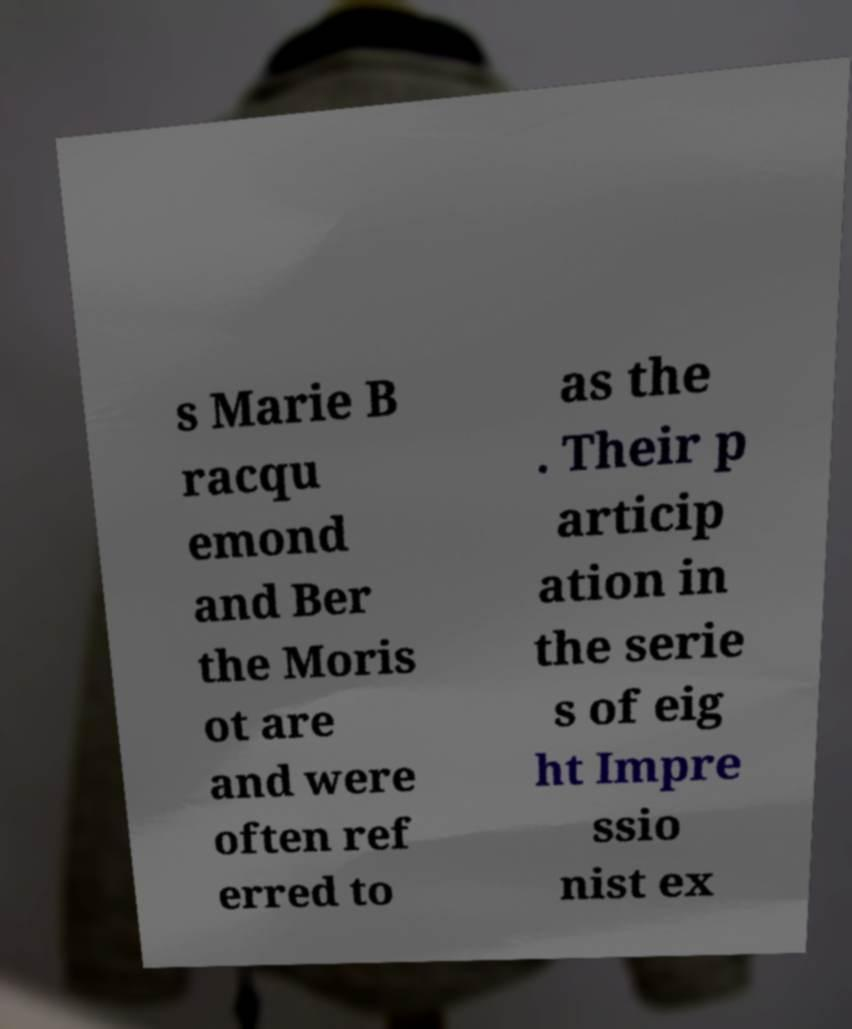Could you extract and type out the text from this image? s Marie B racqu emond and Ber the Moris ot are and were often ref erred to as the . Their p articip ation in the serie s of eig ht Impre ssio nist ex 